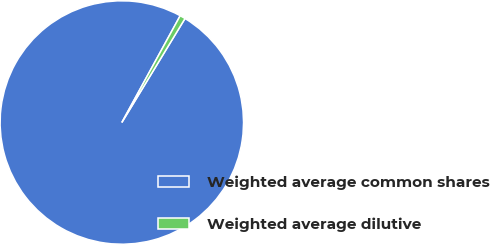Convert chart to OTSL. <chart><loc_0><loc_0><loc_500><loc_500><pie_chart><fcel>Weighted average common shares<fcel>Weighted average dilutive<nl><fcel>99.27%<fcel>0.73%<nl></chart> 